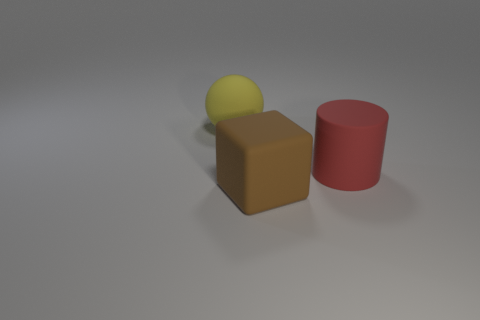Could you tell me what time of day it might be in this scene? Given that this appears to be a computer-generated image with a neutral, non-descript background that lacks context such as a sky or natural light, it's not possible to infer a time of day from this scene. 